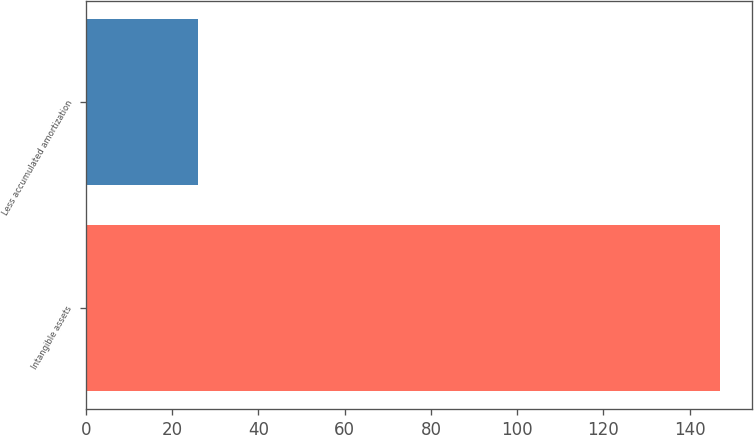Convert chart. <chart><loc_0><loc_0><loc_500><loc_500><bar_chart><fcel>Intangible assets<fcel>Less accumulated amortization<nl><fcel>147<fcel>26<nl></chart> 